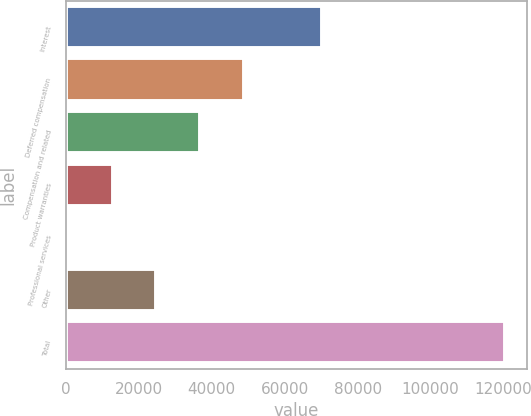Convert chart. <chart><loc_0><loc_0><loc_500><loc_500><bar_chart><fcel>Interest<fcel>Deferred compensation<fcel>Compensation and related<fcel>Product warranties<fcel>Professional services<fcel>Other<fcel>Total<nl><fcel>70109<fcel>48734<fcel>36785.5<fcel>12888.5<fcel>940<fcel>24837<fcel>120425<nl></chart> 